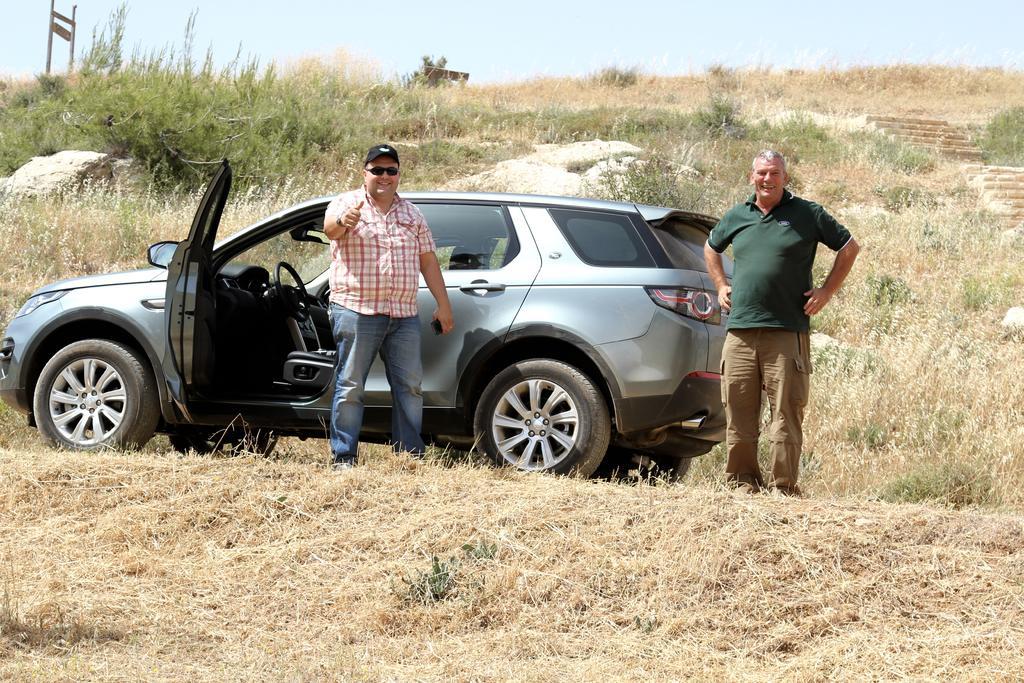Please provide a concise description of this image. In the center of the image we can see one car and we can see two persons are standing and they are smiling. And the left side person is wearing a cap and glasses. In the background we can see the sky, plants, grass, staircases, stones, one sign board etc. 